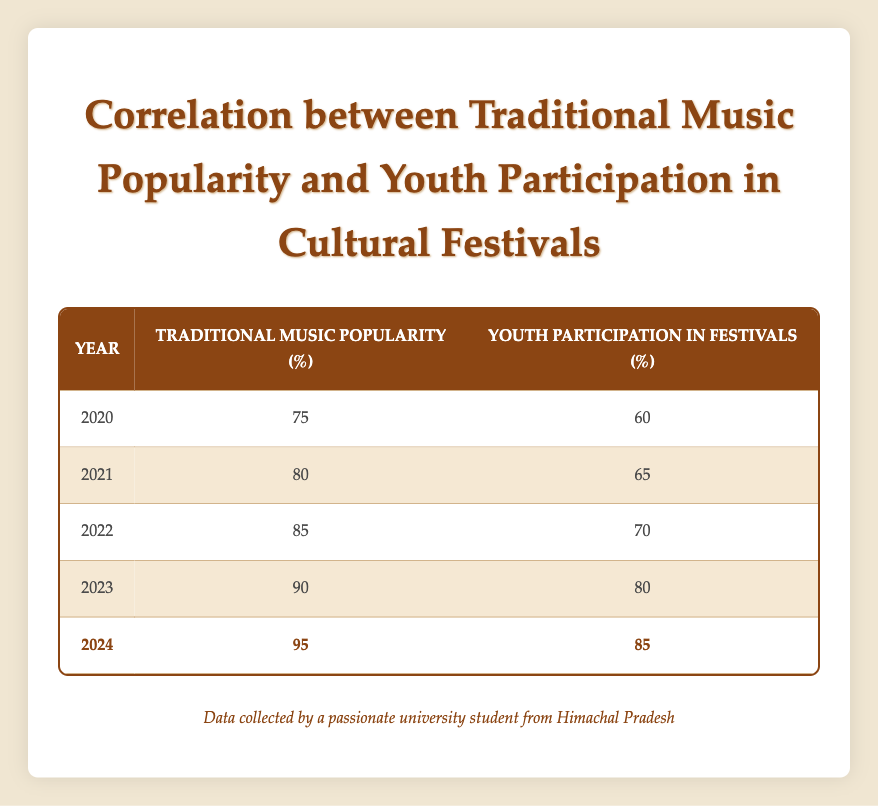What was the highest percentage of youth participation in cultural festivals recorded in the table? The table shows that the highest value for youth participation is 85%, which corresponds to the year 2024.
Answer: 85% In which year did traditional music popularity reach 90%? According to the table, traditional music popularity is 90% in the year 2023.
Answer: 2023 What is the difference in traditional music popularity between 2020 and 2024? In 2020, traditional music popularity was 75%, and in 2024 it was 95%. The difference is 95% - 75% = 20%.
Answer: 20% Is it true that youth participation in festivals was 70% in 2022? By directly looking at the table data for the year 2022, it confirms that youth participation was indeed 70%.
Answer: True What is the average traditional music popularity percentage from 2020 to 2024? The values for traditional music popularity from 2020 to 2024 are 75%, 80%, 85%, 90%, and 95%. The average can be calculated as (75 + 80 + 85 + 90 + 95) / 5 = 85%.
Answer: 85% How much did youth participation in festivals increase from 2020 to 2023? In 2020, youth participation was 60%, and in 2023 it was 80%. The increase can be calculated as 80% - 60% = 20%.
Answer: 20% Did traditional music popularity increase every year from 2020 to 2024? The table data shows that traditional music popularity consistently increased each year from 75% in 2020 to 95% in 2024. Therefore, the statement is true.
Answer: True What year experienced the largest growth in youth participation compared to the previous year? By comparing the values, the growth from 2022 (70%) to 2023 (80%) shows an increase of 10%. In all other comparisons, no other year showed more than a 10% increase. Hence, the largest growth occurred between those years.
Answer: 2023 By how much did traditional music popularity surpass youth participation in 2024? In 2024, traditional music popularity was 95% and youth participation was 85%, leading to a difference of 95% - 85% = 10%.
Answer: 10% 